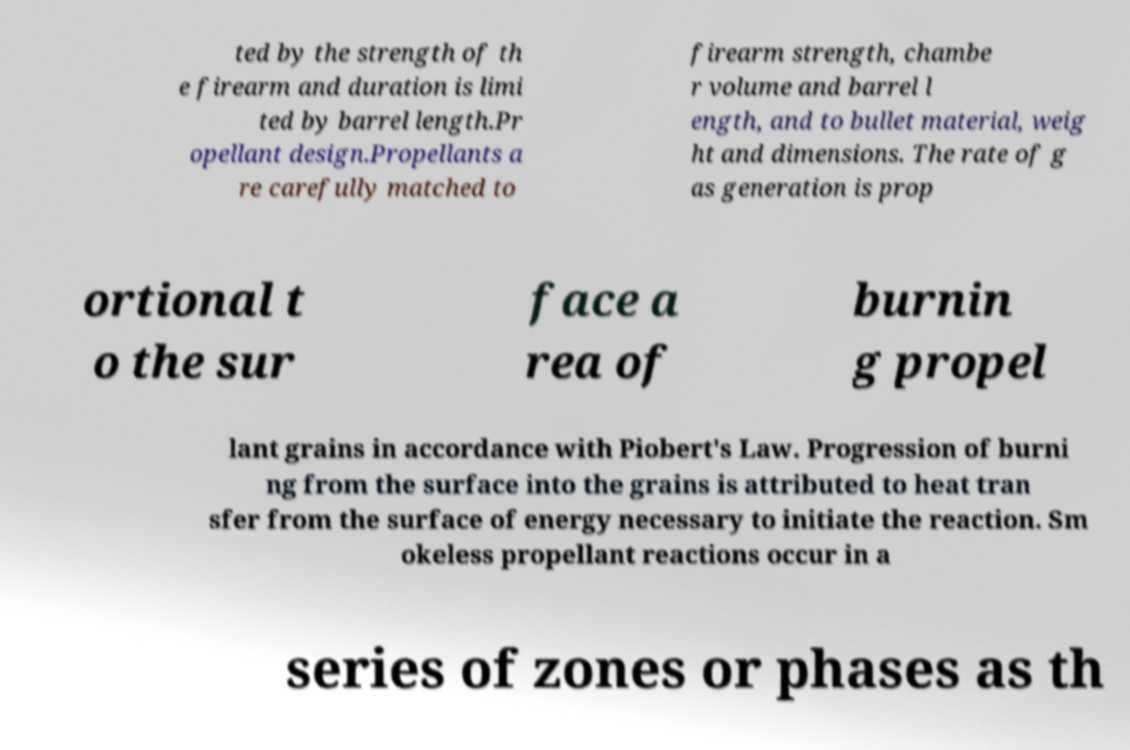What messages or text are displayed in this image? I need them in a readable, typed format. ted by the strength of th e firearm and duration is limi ted by barrel length.Pr opellant design.Propellants a re carefully matched to firearm strength, chambe r volume and barrel l ength, and to bullet material, weig ht and dimensions. The rate of g as generation is prop ortional t o the sur face a rea of burnin g propel lant grains in accordance with Piobert's Law. Progression of burni ng from the surface into the grains is attributed to heat tran sfer from the surface of energy necessary to initiate the reaction. Sm okeless propellant reactions occur in a series of zones or phases as th 